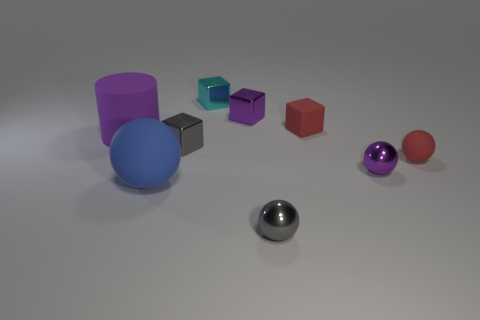Subtract all cylinders. How many objects are left? 8 Add 9 gray cubes. How many gray cubes are left? 10 Add 5 tiny purple spheres. How many tiny purple spheres exist? 6 Subtract 0 blue cylinders. How many objects are left? 9 Subtract all tiny cubes. Subtract all large green metallic cubes. How many objects are left? 5 